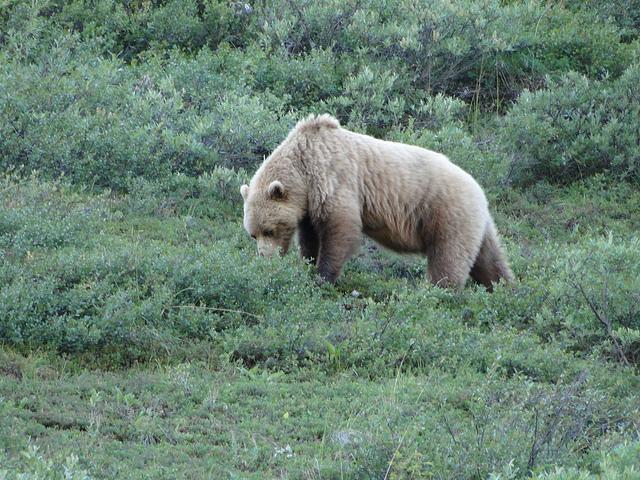What type of animal is in this picture?
Answer briefly. Bear. What color is the animal?
Quick response, please. Brown. Where is this picture taken?
Give a very brief answer. Outside. Is the cameraman too close?
Short answer required. No. 